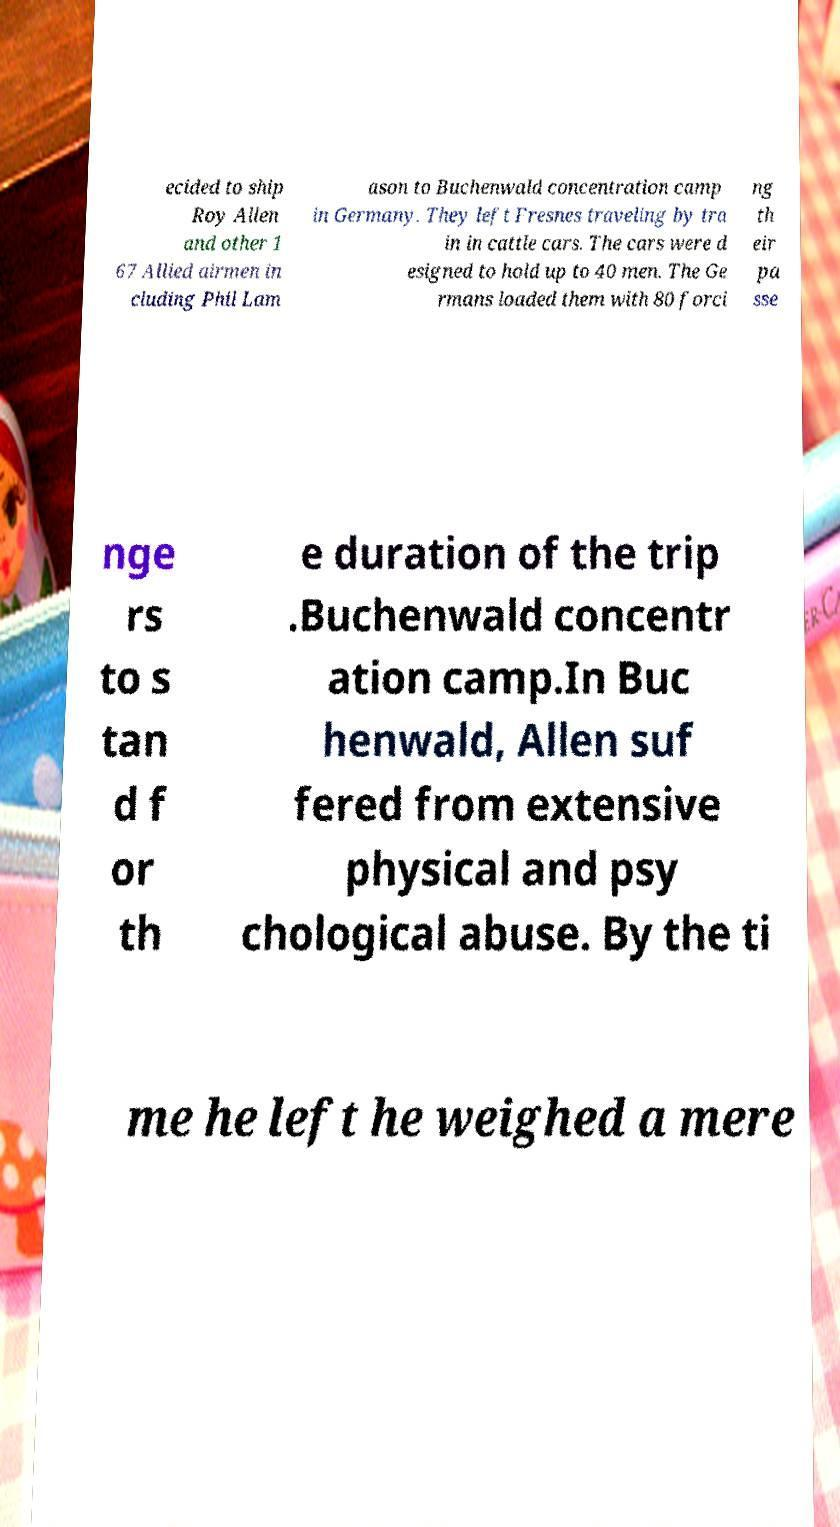Please read and relay the text visible in this image. What does it say? ecided to ship Roy Allen and other 1 67 Allied airmen in cluding Phil Lam ason to Buchenwald concentration camp in Germany. They left Fresnes traveling by tra in in cattle cars. The cars were d esigned to hold up to 40 men. The Ge rmans loaded them with 80 forci ng th eir pa sse nge rs to s tan d f or th e duration of the trip .Buchenwald concentr ation camp.In Buc henwald, Allen suf fered from extensive physical and psy chological abuse. By the ti me he left he weighed a mere 